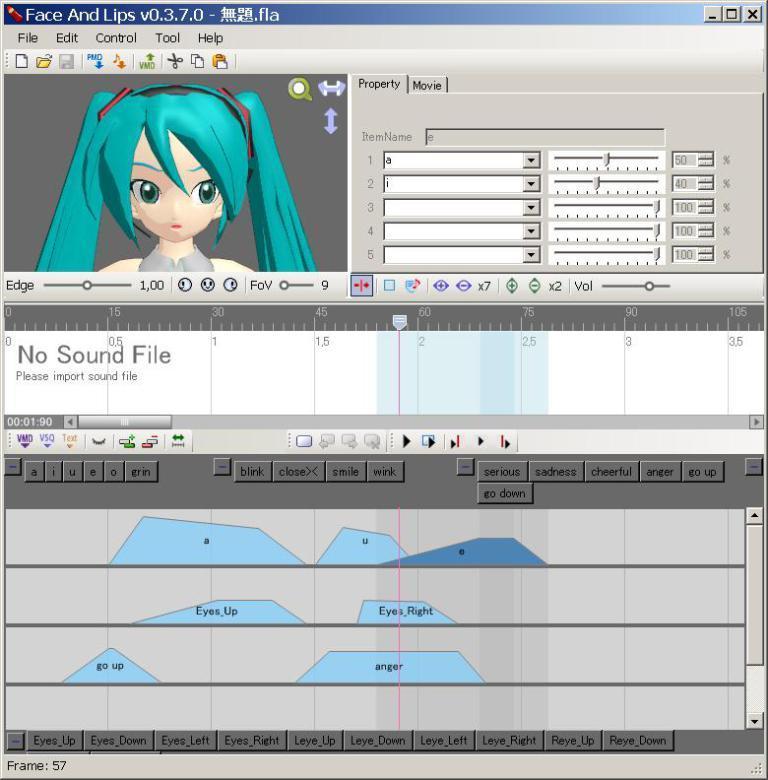Describe this image in one or two sentences. In the image in the center we can see one web page. And on the left top of the image we can see one cartoon image. 